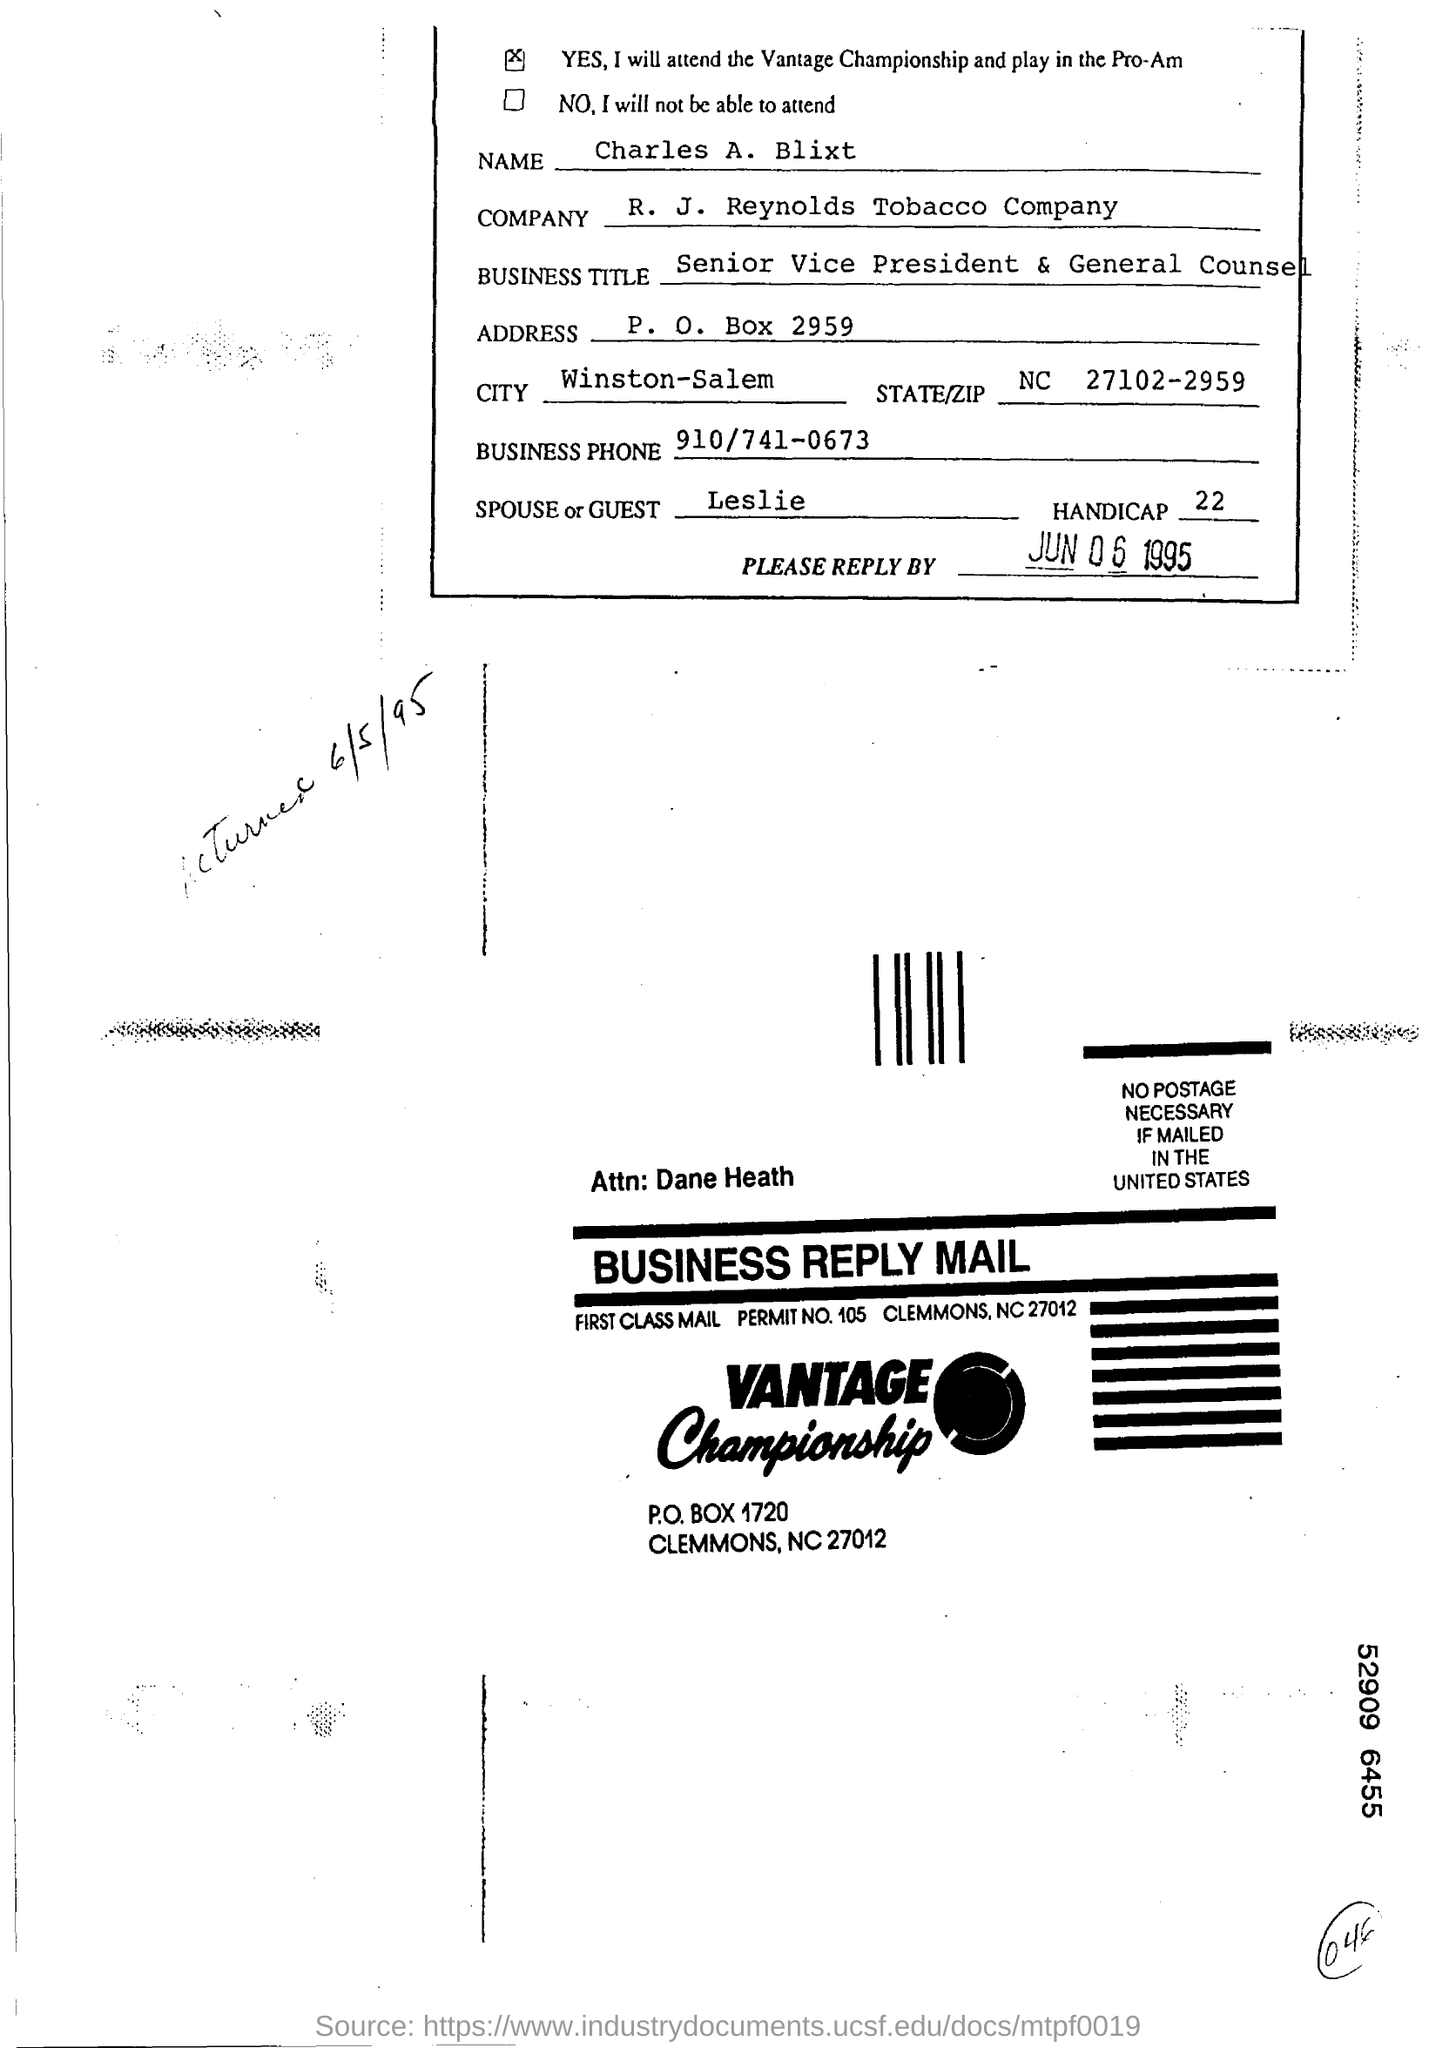What is the business title of charles a. blixt ?
Provide a succinct answer. Senior Vice President & General Counsel. What is the business title of Charles A. Blixt?
Offer a terse response. Senior Vice President & General Counsel. What is the spouse or guest name ?
Your response must be concise. Leslie. What is the business phone number ?
Make the answer very short. 910/741-0673. 